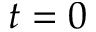<formula> <loc_0><loc_0><loc_500><loc_500>t = 0</formula> 